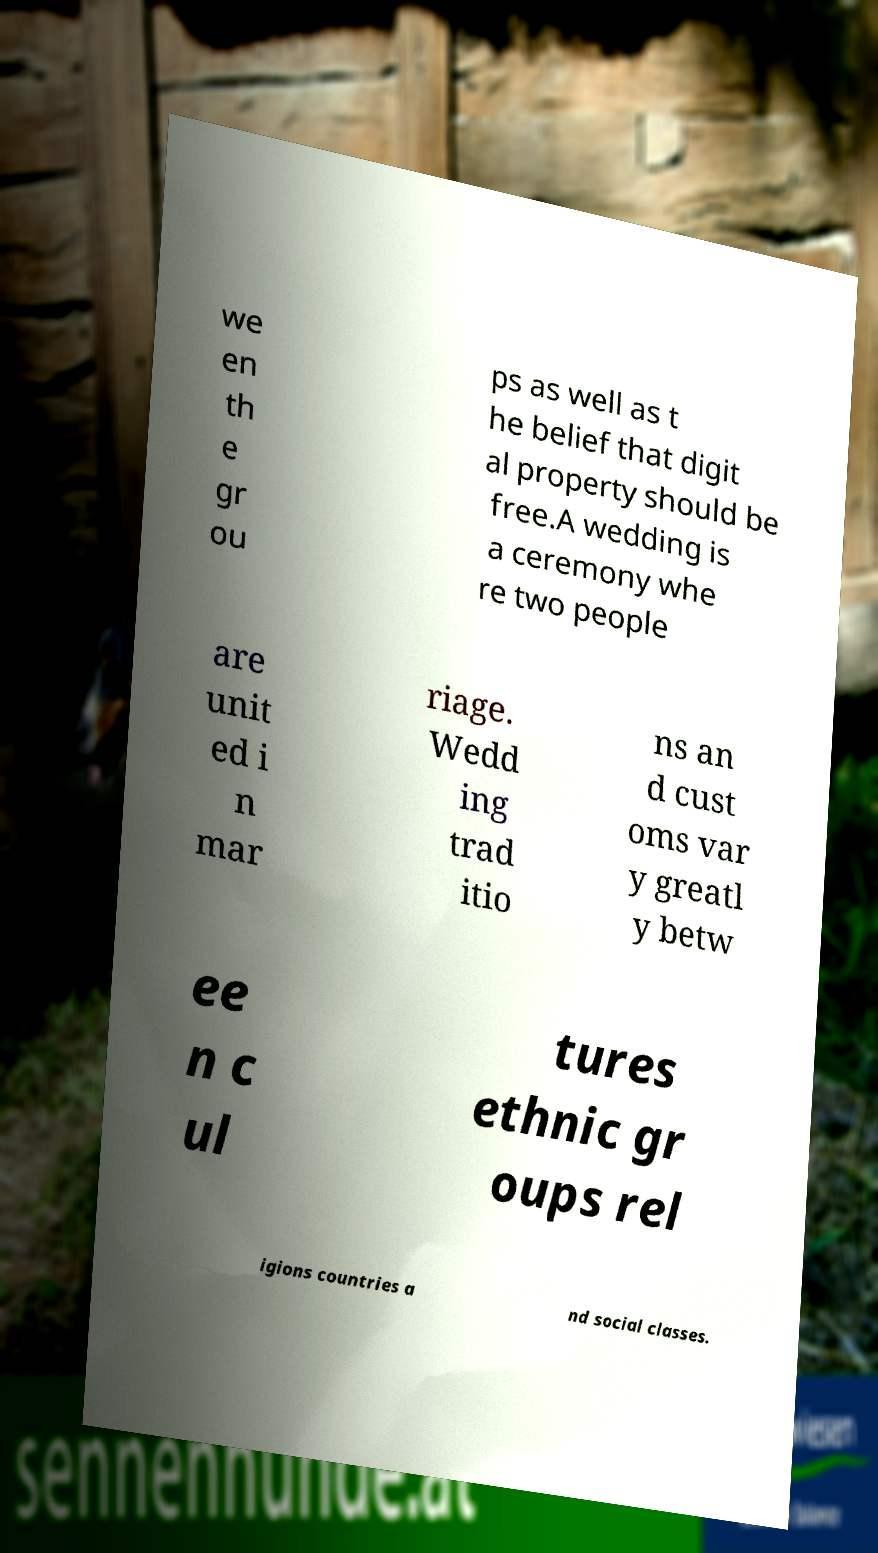Can you accurately transcribe the text from the provided image for me? we en th e gr ou ps as well as t he belief that digit al property should be free.A wedding is a ceremony whe re two people are unit ed i n mar riage. Wedd ing trad itio ns an d cust oms var y greatl y betw ee n c ul tures ethnic gr oups rel igions countries a nd social classes. 